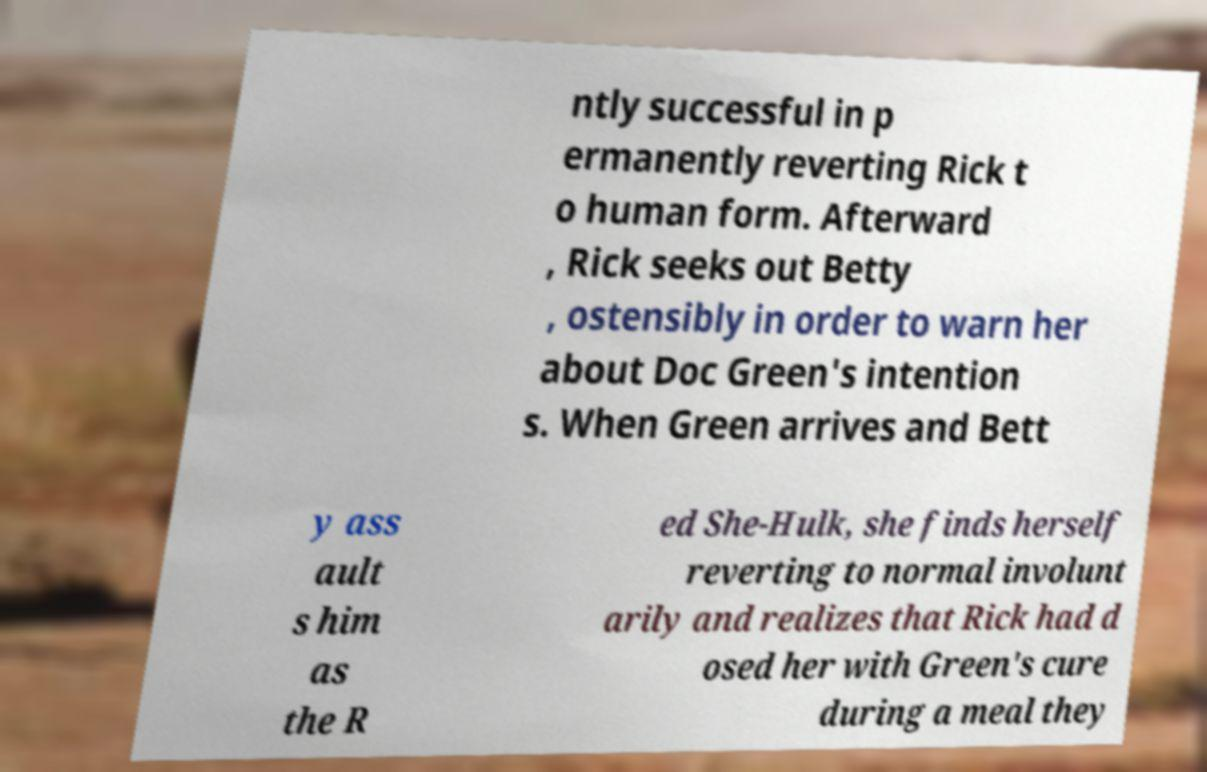Could you extract and type out the text from this image? ntly successful in p ermanently reverting Rick t o human form. Afterward , Rick seeks out Betty , ostensibly in order to warn her about Doc Green's intention s. When Green arrives and Bett y ass ault s him as the R ed She-Hulk, she finds herself reverting to normal involunt arily and realizes that Rick had d osed her with Green's cure during a meal they 